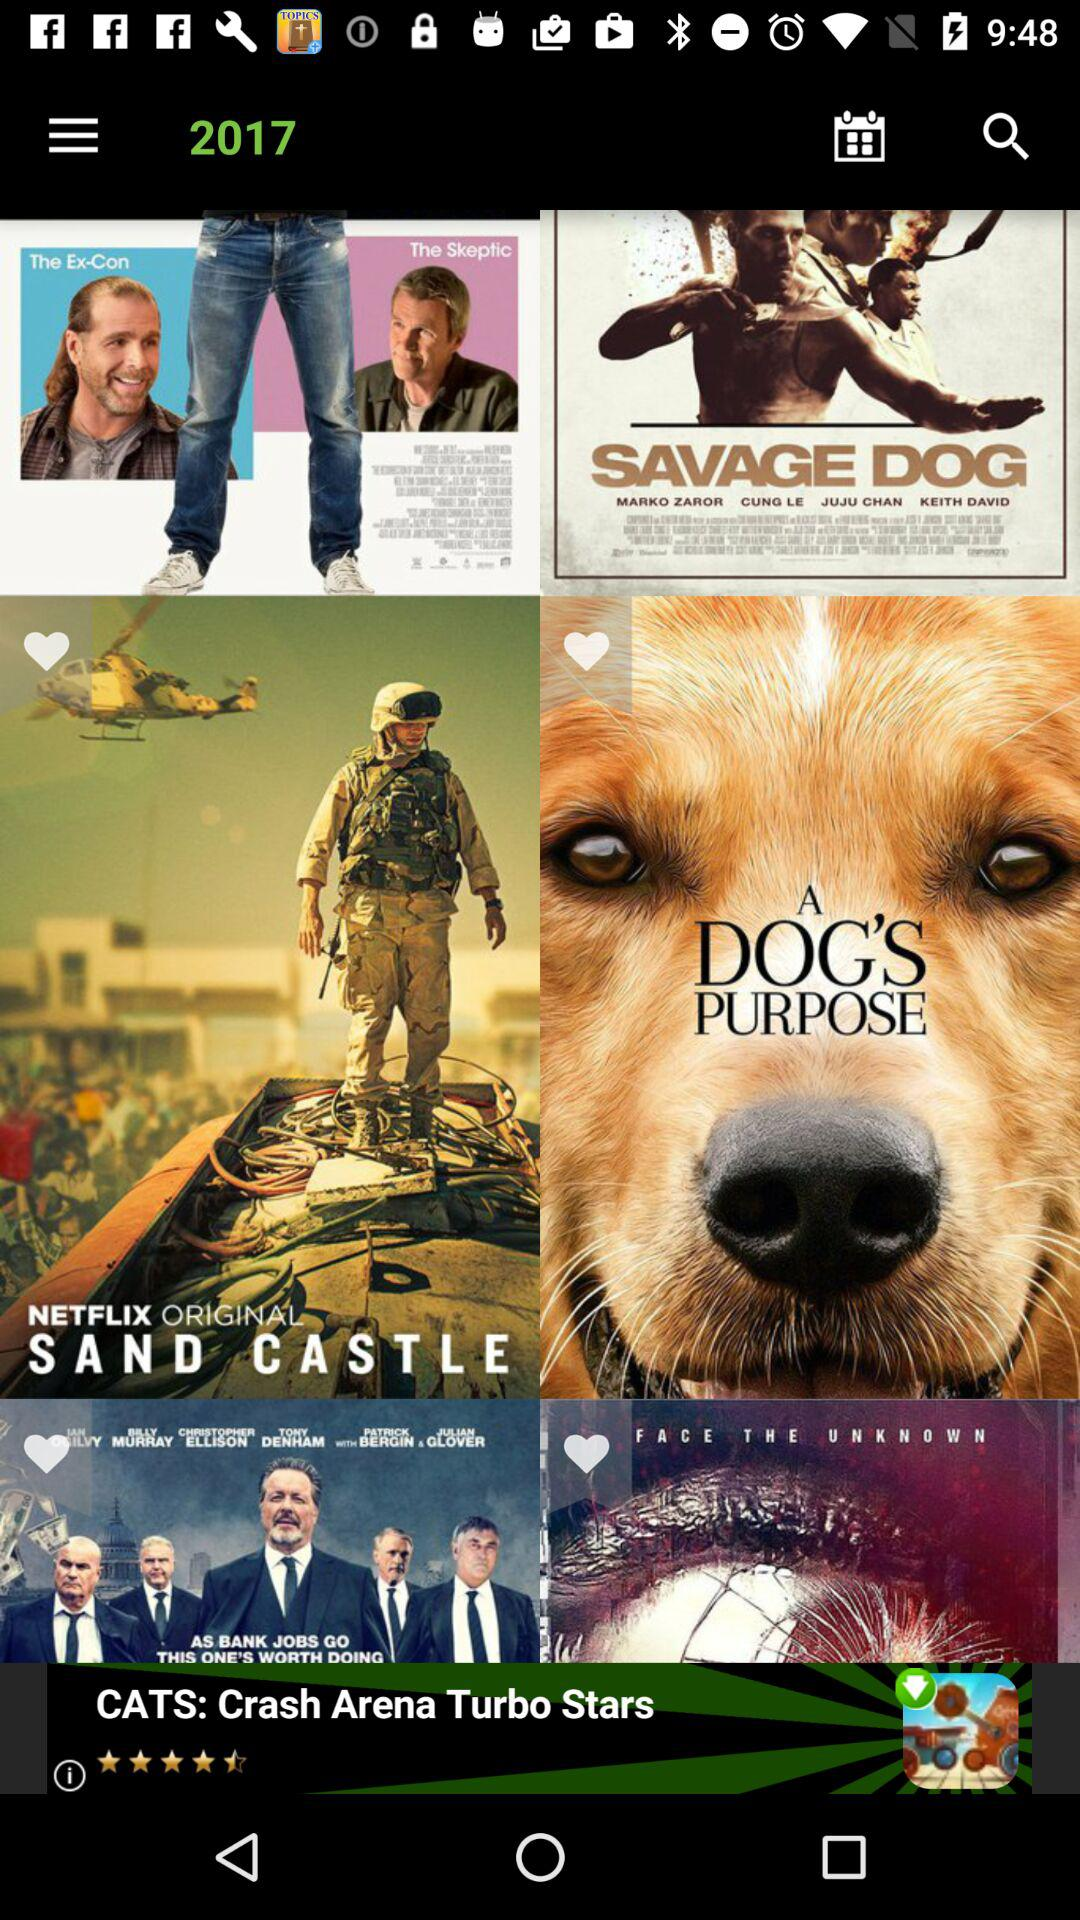What is the year? The year is 2017. 